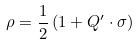Convert formula to latex. <formula><loc_0><loc_0><loc_500><loc_500>\rho = \frac { 1 } { 2 } \left ( 1 + { Q ^ { \prime } \cdot \sigma } \right )</formula> 